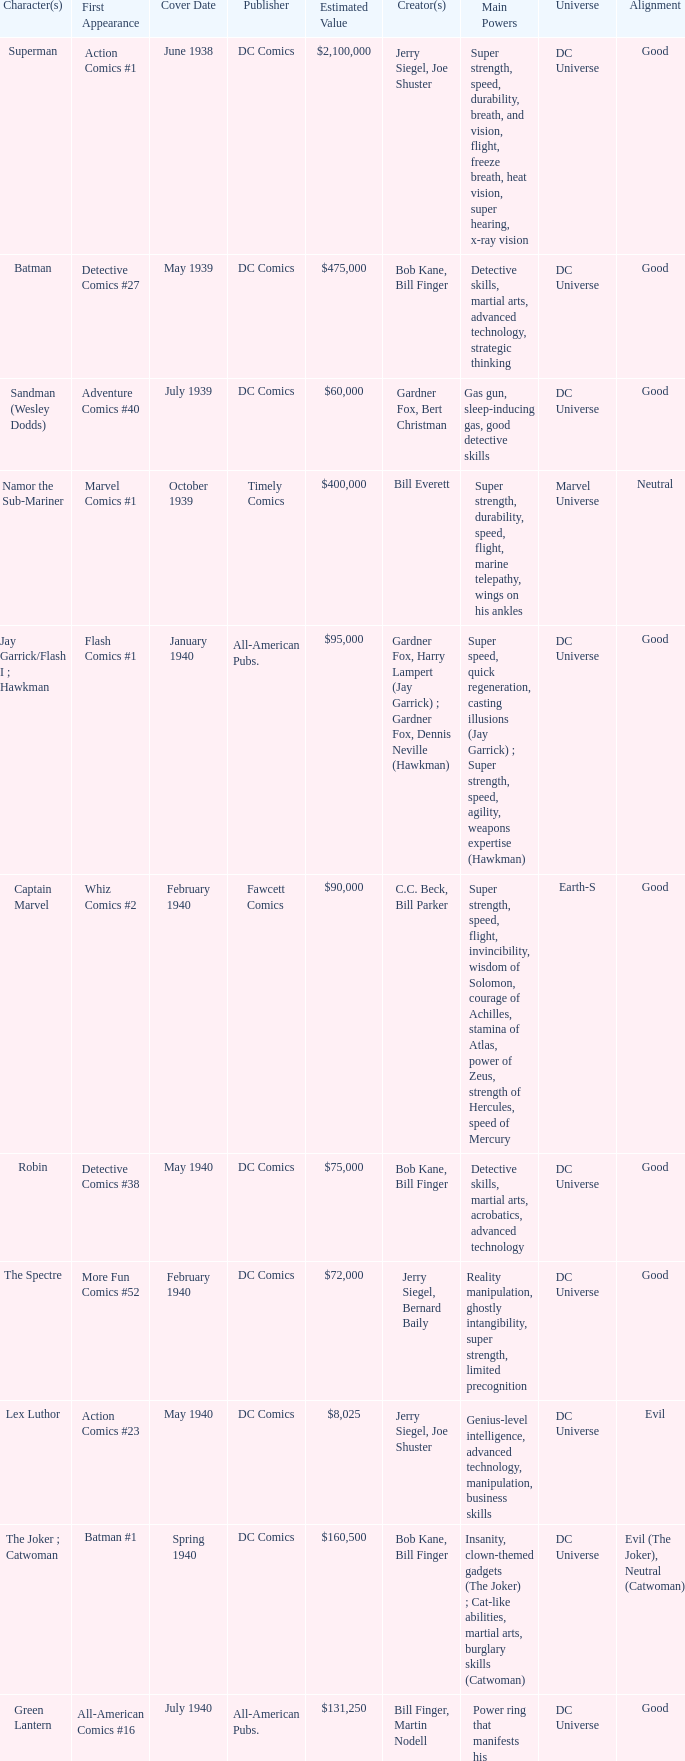What is Action Comics #1's estimated value? $2,100,000. 